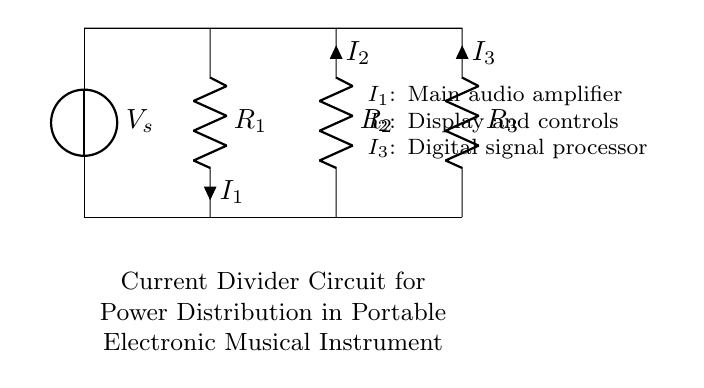What is the source voltage in this circuit? The source voltage, represented as V_s, is indicated at the top of the circuit diagram. The value isn't specified, but it is labeled as the source voltage of the circuit.
Answer: V_s What are the values of the resistors? The circuit diagram does not specify numeric values for resistors R1, R2, and R3; it only labels them. To find the exact values, you would need additional information or specifications from design documents.
Answer: Not provided What is the role of I1 in this circuit? I1 is identified in the circuit diagram as the current flowing through resistor R1, which represents the main audio amplifier's power distribution requirement.
Answer: Main audio amplifier How many resistors are present in the current divider circuit? The circuit diagram shows a total of three resistors: R1, R2, and R3. Simple counting of the components indicated confirms this.
Answer: Three How does current divide among the resistors? The current will divide based on the resistance values of R1, R2, and R3, with less current flowing through a higher resistance and more through a lower resistance according to Ohm's Law. Specific values would require knowing actual resistance values.
Answer: Based on resistance values What is the purpose of the current divider circuit in portable instruments? The current divider circuit is used for managing power distribution, ensuring that each component (audio amplifier, display, digital signal processor) receives appropriate power for proper functionality in a portable electronic musical instrument.
Answer: Power distribution What is the direction of current I2? Current I2 is indicated to flow into resistor R2, which provides power for the display and control systems, as denoted by the directional arrow on the circuit diagram.
Answer: Into R2 